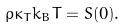Convert formula to latex. <formula><loc_0><loc_0><loc_500><loc_500>\rho \kappa _ { T } k _ { B } T = S ( 0 ) .</formula> 